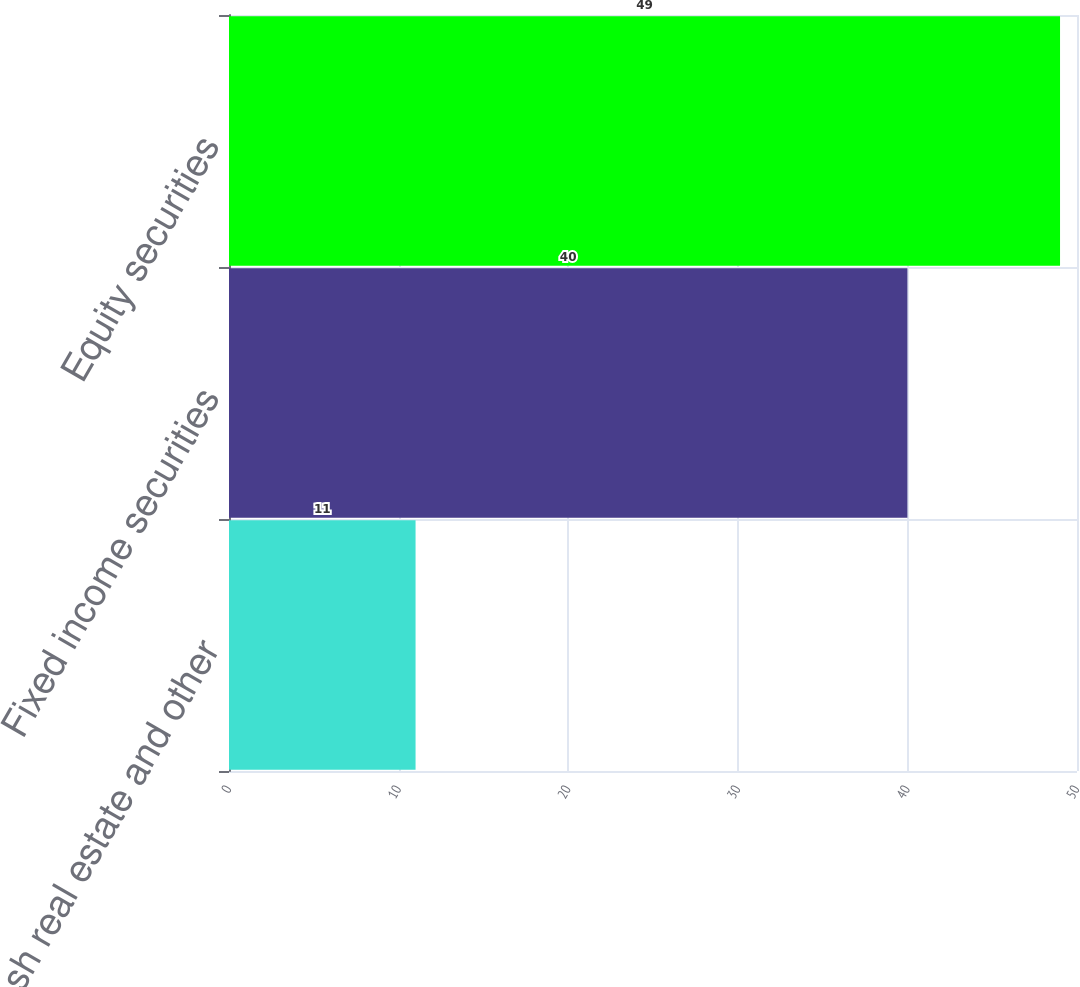<chart> <loc_0><loc_0><loc_500><loc_500><bar_chart><fcel>Cash real estate and other<fcel>Fixed income securities<fcel>Equity securities<nl><fcel>11<fcel>40<fcel>49<nl></chart> 